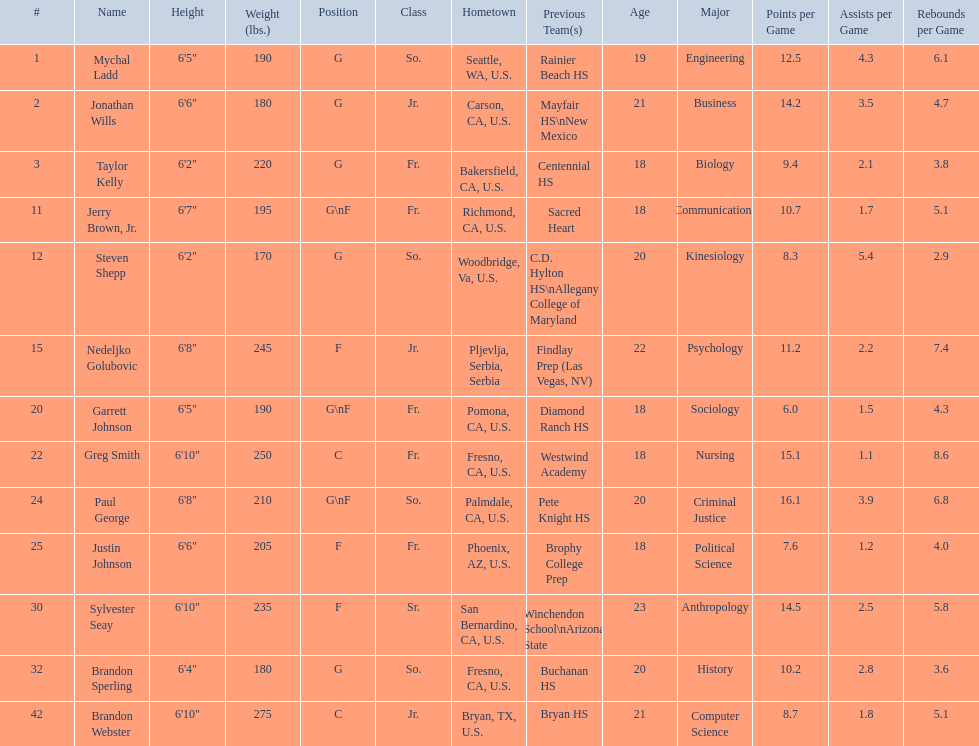Would you mind parsing the complete table? {'header': ['#', 'Name', 'Height', 'Weight (lbs.)', 'Position', 'Class', 'Hometown', 'Previous Team(s)', 'Age', 'Major', 'Points per Game', 'Assists per Game', 'Rebounds per Game'], 'rows': [['1', 'Mychal Ladd', '6\'5"', '190', 'G', 'So.', 'Seattle, WA, U.S.', 'Rainier Beach HS', '19', 'Engineering', '12.5', '4.3', '6.1'], ['2', 'Jonathan Wills', '6\'6"', '180', 'G', 'Jr.', 'Carson, CA, U.S.', 'Mayfair HS\\nNew Mexico', '21', 'Business', '14.2', '3.5', '4.7'], ['3', 'Taylor Kelly', '6\'2"', '220', 'G', 'Fr.', 'Bakersfield, CA, U.S.', 'Centennial HS', '18', 'Biology', '9.4', '2.1', '3.8'], ['11', 'Jerry Brown, Jr.', '6\'7"', '195', 'G\\nF', 'Fr.', 'Richmond, CA, U.S.', 'Sacred Heart', '18', 'Communications', '10.7', '1.7', '5.1'], ['12', 'Steven Shepp', '6\'2"', '170', 'G', 'So.', 'Woodbridge, Va, U.S.', 'C.D. Hylton HS\\nAllegany College of Maryland', '20', 'Kinesiology', '8.3', '5.4', '2.9'], ['15', 'Nedeljko Golubovic', '6\'8"', '245', 'F', 'Jr.', 'Pljevlja, Serbia, Serbia', 'Findlay Prep (Las Vegas, NV)', '22', 'Psychology', '11.2', '2.2', '7.4'], ['20', 'Garrett Johnson', '6\'5"', '190', 'G\\nF', 'Fr.', 'Pomona, CA, U.S.', 'Diamond Ranch HS', '18', 'Sociology', '6.0', '1.5', '4.3'], ['22', 'Greg Smith', '6\'10"', '250', 'C', 'Fr.', 'Fresno, CA, U.S.', 'Westwind Academy', '18', 'Nursing', '15.1', '1.1', '8.6'], ['24', 'Paul George', '6\'8"', '210', 'G\\nF', 'So.', 'Palmdale, CA, U.S.', 'Pete Knight HS', '20', 'Criminal Justice', '16.1', '3.9', '6.8'], ['25', 'Justin Johnson', '6\'6"', '205', 'F', 'Fr.', 'Phoenix, AZ, U.S.', 'Brophy College Prep', '18', 'Political Science', '7.6', '1.2', '4.0'], ['30', 'Sylvester Seay', '6\'10"', '235', 'F', 'Sr.', 'San Bernardino, CA, U.S.', 'Winchendon School\\nArizona State', '23', 'Anthropology', '14.5', '2.5', '5.8'], ['32', 'Brandon Sperling', '6\'4"', '180', 'G', 'So.', 'Fresno, CA, U.S.', 'Buchanan HS', '20', 'History', '10.2', '2.8', '3.6'], ['42', 'Brandon Webster', '6\'10"', '275', 'C', 'Jr.', 'Bryan, TX, U.S.', 'Bryan HS', '21', 'Computer Science', '8.7', '1.8', '5.1']]} What are the names of the basketball team players? Mychal Ladd, Jonathan Wills, Taylor Kelly, Jerry Brown, Jr., Steven Shepp, Nedeljko Golubovic, Garrett Johnson, Greg Smith, Paul George, Justin Johnson, Sylvester Seay, Brandon Sperling, Brandon Webster. Of these identify paul george and greg smith Greg Smith, Paul George. What are their corresponding heights? 6'10", 6'8". To who does the larger height correspond to? Greg Smith. 